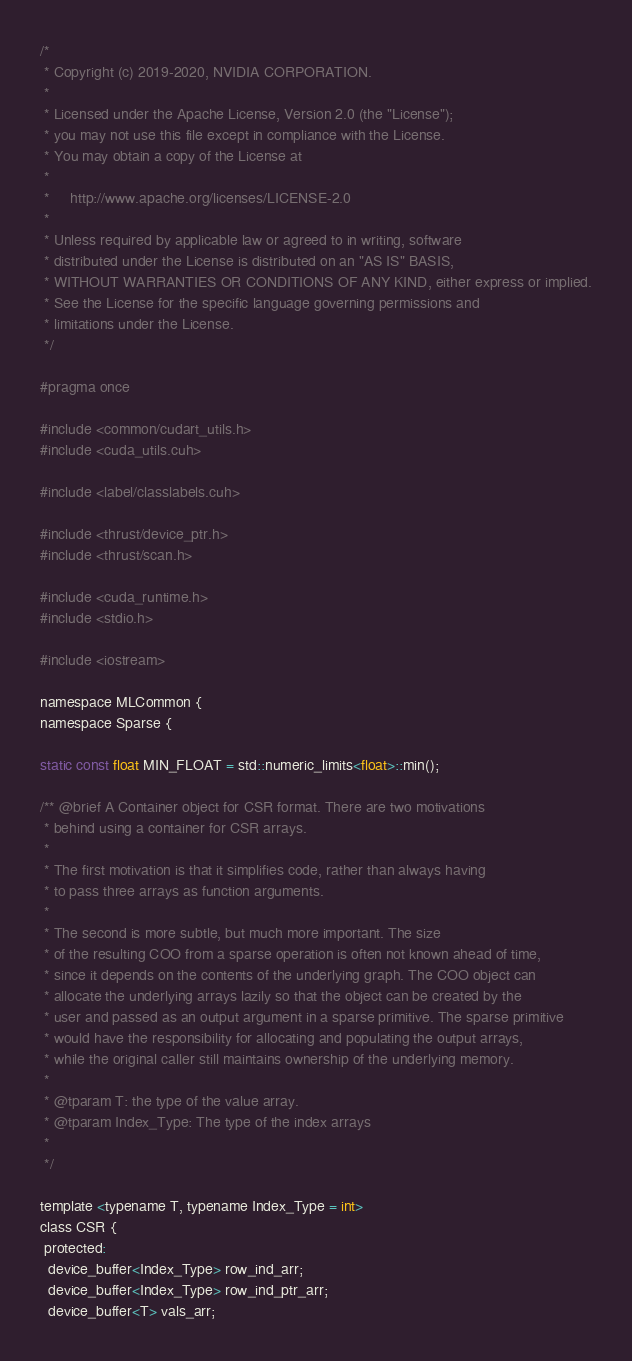<code> <loc_0><loc_0><loc_500><loc_500><_Cuda_>/*
 * Copyright (c) 2019-2020, NVIDIA CORPORATION.
 *
 * Licensed under the Apache License, Version 2.0 (the "License");
 * you may not use this file except in compliance with the License.
 * You may obtain a copy of the License at
 *
 *     http://www.apache.org/licenses/LICENSE-2.0
 *
 * Unless required by applicable law or agreed to in writing, software
 * distributed under the License is distributed on an "AS IS" BASIS,
 * WITHOUT WARRANTIES OR CONDITIONS OF ANY KIND, either express or implied.
 * See the License for the specific language governing permissions and
 * limitations under the License.
 */

#pragma once

#include <common/cudart_utils.h>
#include <cuda_utils.cuh>

#include <label/classlabels.cuh>

#include <thrust/device_ptr.h>
#include <thrust/scan.h>

#include <cuda_runtime.h>
#include <stdio.h>

#include <iostream>

namespace MLCommon {
namespace Sparse {

static const float MIN_FLOAT = std::numeric_limits<float>::min();

/** @brief A Container object for CSR format. There are two motivations
 * behind using a container for CSR arrays.
 *
 * The first motivation is that it simplifies code, rather than always having
 * to pass three arrays as function arguments.
 *
 * The second is more subtle, but much more important. The size
 * of the resulting COO from a sparse operation is often not known ahead of time,
 * since it depends on the contents of the underlying graph. The COO object can
 * allocate the underlying arrays lazily so that the object can be created by the
 * user and passed as an output argument in a sparse primitive. The sparse primitive
 * would have the responsibility for allocating and populating the output arrays,
 * while the original caller still maintains ownership of the underlying memory.
 *
 * @tparam T: the type of the value array.
 * @tparam Index_Type: The type of the index arrays
 *
 */

template <typename T, typename Index_Type = int>
class CSR {
 protected:
  device_buffer<Index_Type> row_ind_arr;
  device_buffer<Index_Type> row_ind_ptr_arr;
  device_buffer<T> vals_arr;
</code> 